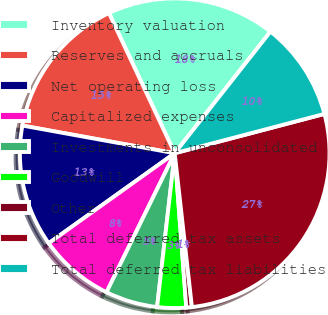<chart> <loc_0><loc_0><loc_500><loc_500><pie_chart><fcel>Inventory valuation<fcel>Reserves and accruals<fcel>Net operating loss<fcel>Capitalized expenses<fcel>Investments in unconsolidated<fcel>Goodwill<fcel>Other<fcel>Total deferred tax assets<fcel>Total deferred tax liabilities<nl><fcel>17.59%<fcel>15.16%<fcel>12.73%<fcel>7.87%<fcel>5.44%<fcel>3.01%<fcel>0.58%<fcel>27.31%<fcel>10.3%<nl></chart> 